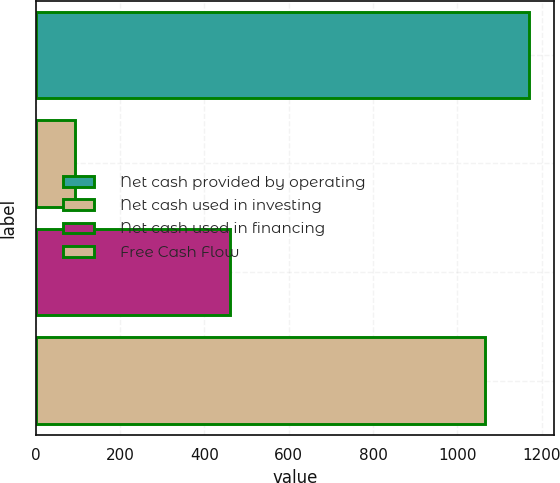Convert chart. <chart><loc_0><loc_0><loc_500><loc_500><bar_chart><fcel>Net cash provided by operating<fcel>Net cash used in investing<fcel>Net cash used in financing<fcel>Free Cash Flow<nl><fcel>1170.76<fcel>92<fcel>461<fcel>1064.6<nl></chart> 